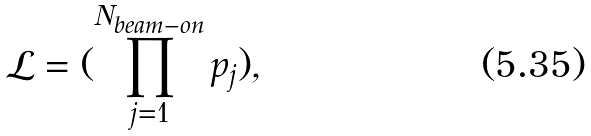<formula> <loc_0><loc_0><loc_500><loc_500>\mathcal { L } = ( \prod _ { j = 1 } ^ { N _ { b e a m - o n } } p _ { j } ) ,</formula> 